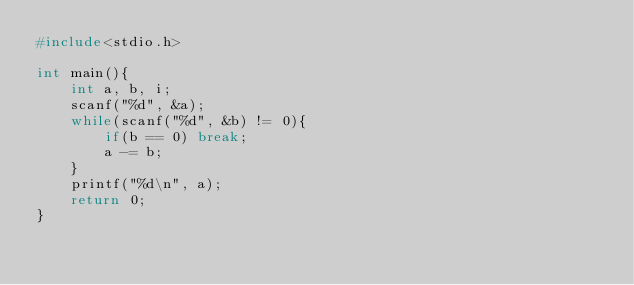Convert code to text. <code><loc_0><loc_0><loc_500><loc_500><_C_>#include<stdio.h>
 
int main(){
	int a, b, i;
	scanf("%d", &a);
	while(scanf("%d", &b) != 0){
		if(b == 0) break;
		a -= b;
	}
	printf("%d\n", a);
	return 0;
}</code> 